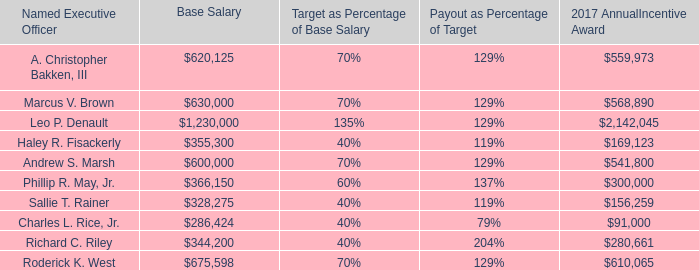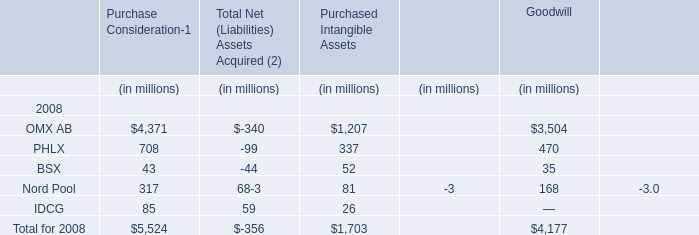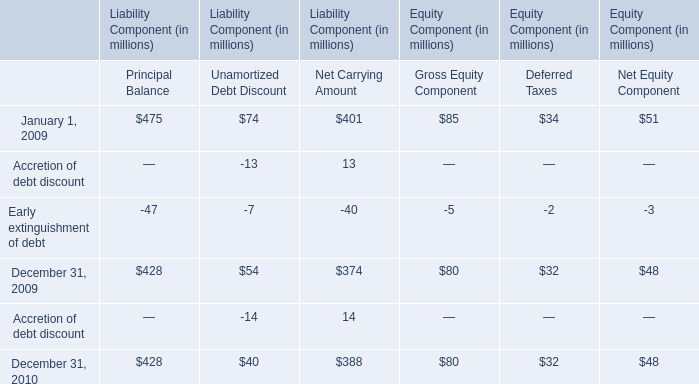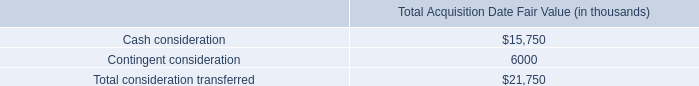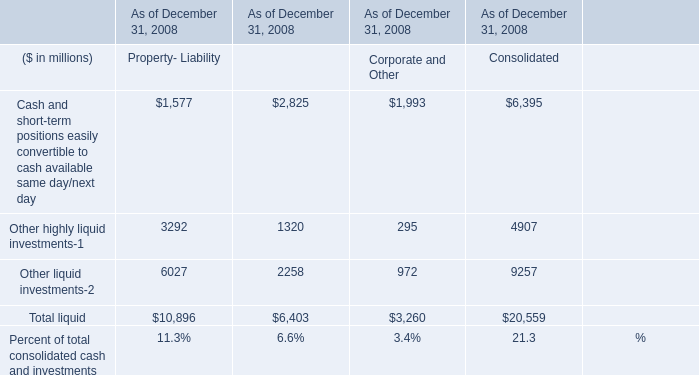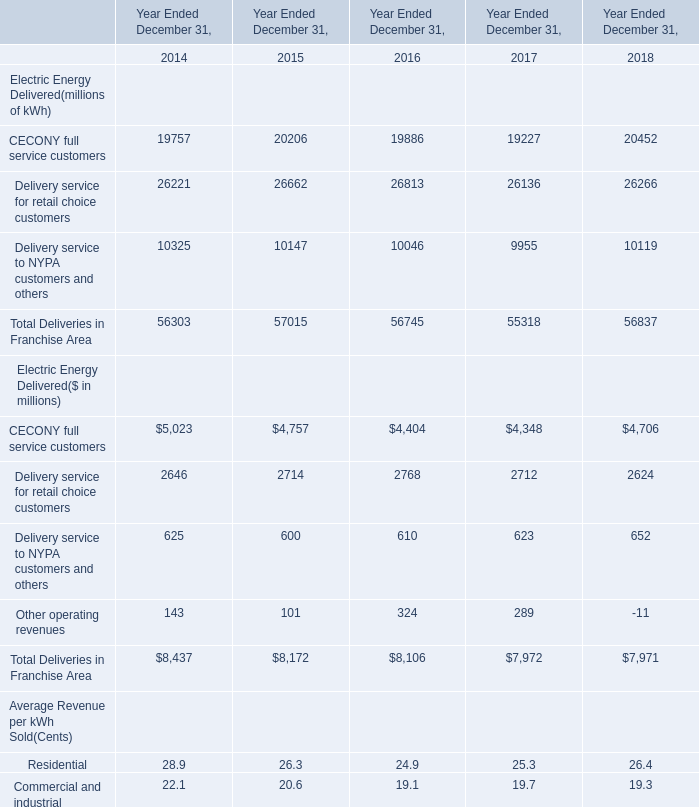What is the sum of Nord Pool of Purchase Consideration in 2008 and Principal Balance of Liability Component in 2010? (in million) 
Computations: (317 + 428)
Answer: 745.0. 